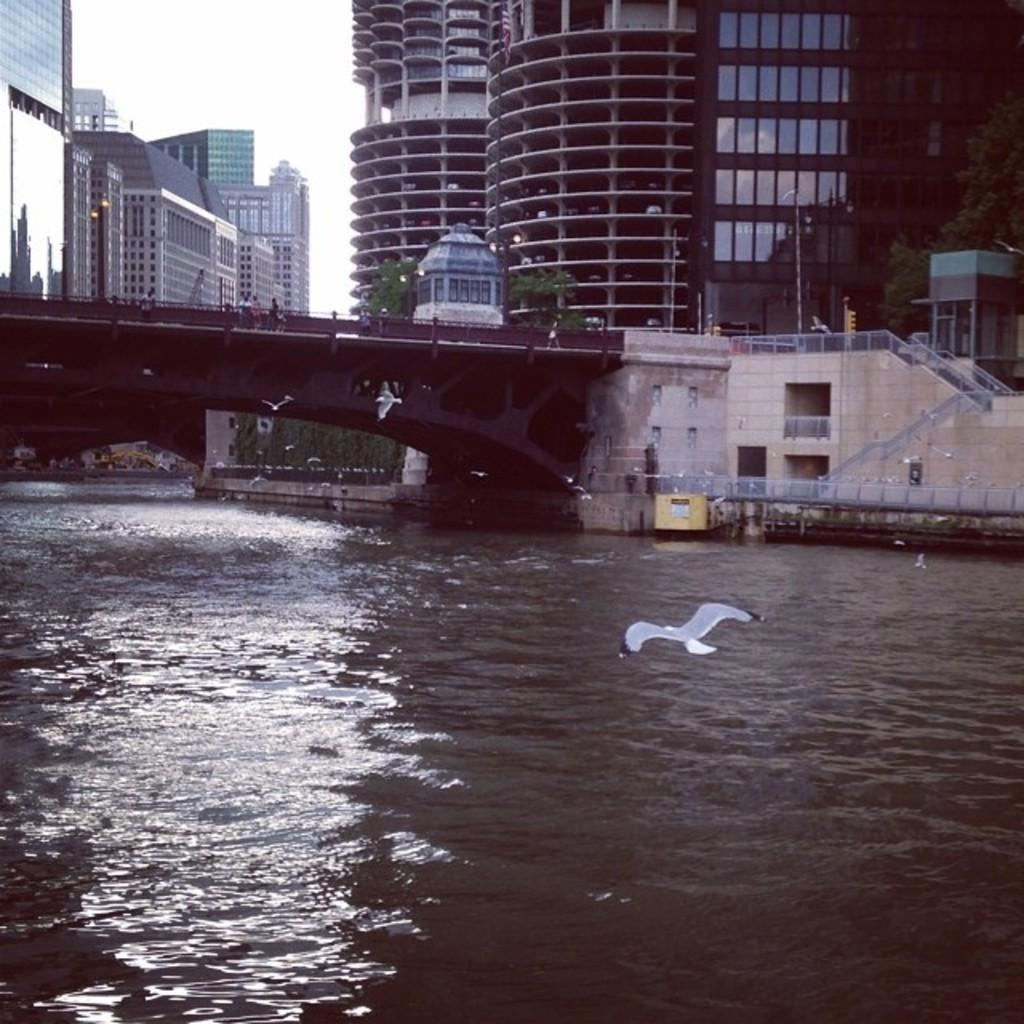What type of structures can be seen in the image? There are buildings in the image. What connects the two sides of the water in the image? There is a bridge in the image. Can you describe the people in the image? There are people in the image. What natural element is visible in the image? There is water visible in the image. What part of the sky is visible in the image? There is sky visible in the image. What animal can be seen in the image? There is a bird flying in the image. Where is the oven located in the image? There is no oven present in the image. What type of powder can be seen covering the people in the image? There is no powder visible on the people in the image. 